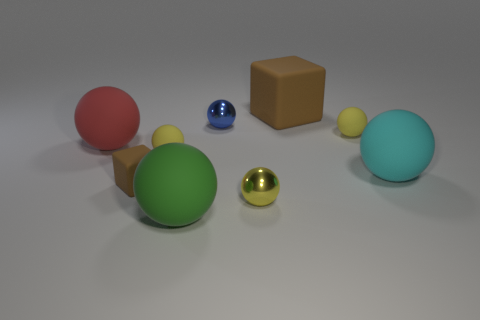Subtract all rubber balls. How many balls are left? 2 Add 1 big red things. How many objects exist? 10 Subtract all cyan spheres. How many spheres are left? 6 Subtract 1 blocks. How many blocks are left? 1 Subtract 0 gray spheres. How many objects are left? 9 Subtract all blocks. How many objects are left? 7 Subtract all purple cubes. Subtract all purple spheres. How many cubes are left? 2 Subtract all cyan balls. How many cyan cubes are left? 0 Subtract all big cyan spheres. Subtract all tiny objects. How many objects are left? 3 Add 1 matte balls. How many matte balls are left? 6 